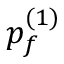Convert formula to latex. <formula><loc_0><loc_0><loc_500><loc_500>p _ { f } ^ { ( 1 ) }</formula> 